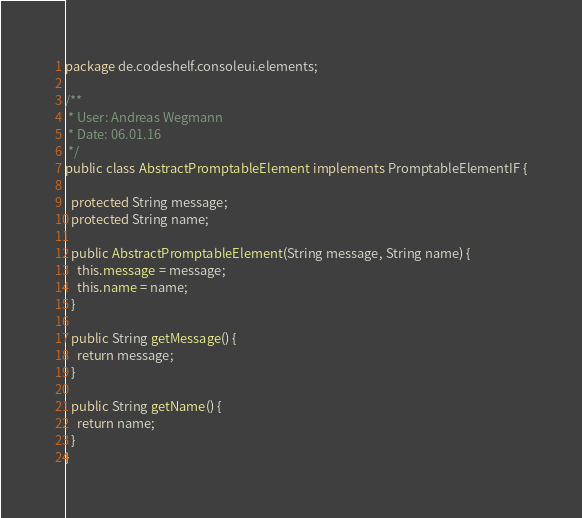Convert code to text. <code><loc_0><loc_0><loc_500><loc_500><_Java_>package de.codeshelf.consoleui.elements;

/**
 * User: Andreas Wegmann
 * Date: 06.01.16
 */
public class AbstractPromptableElement implements PromptableElementIF {

  protected String message;
  protected String name;

  public AbstractPromptableElement(String message, String name) {
    this.message = message;
    this.name = name;
  }

  public String getMessage() {
    return message;
  }

  public String getName() {
    return name;
  }
}
</code> 